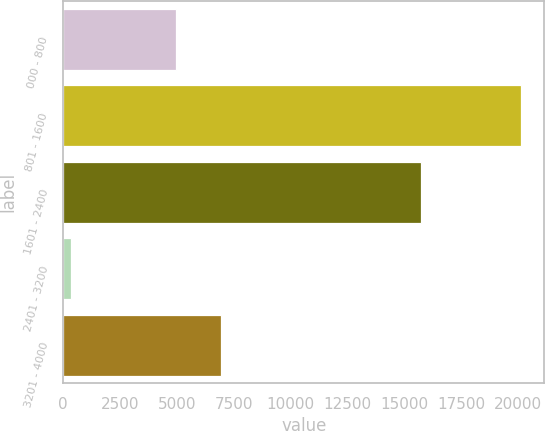Convert chart. <chart><loc_0><loc_0><loc_500><loc_500><bar_chart><fcel>000 - 800<fcel>801 - 1600<fcel>1601 - 2400<fcel>2401 - 3200<fcel>3201 - 4000<nl><fcel>4980<fcel>20161<fcel>15764<fcel>358<fcel>6960.3<nl></chart> 